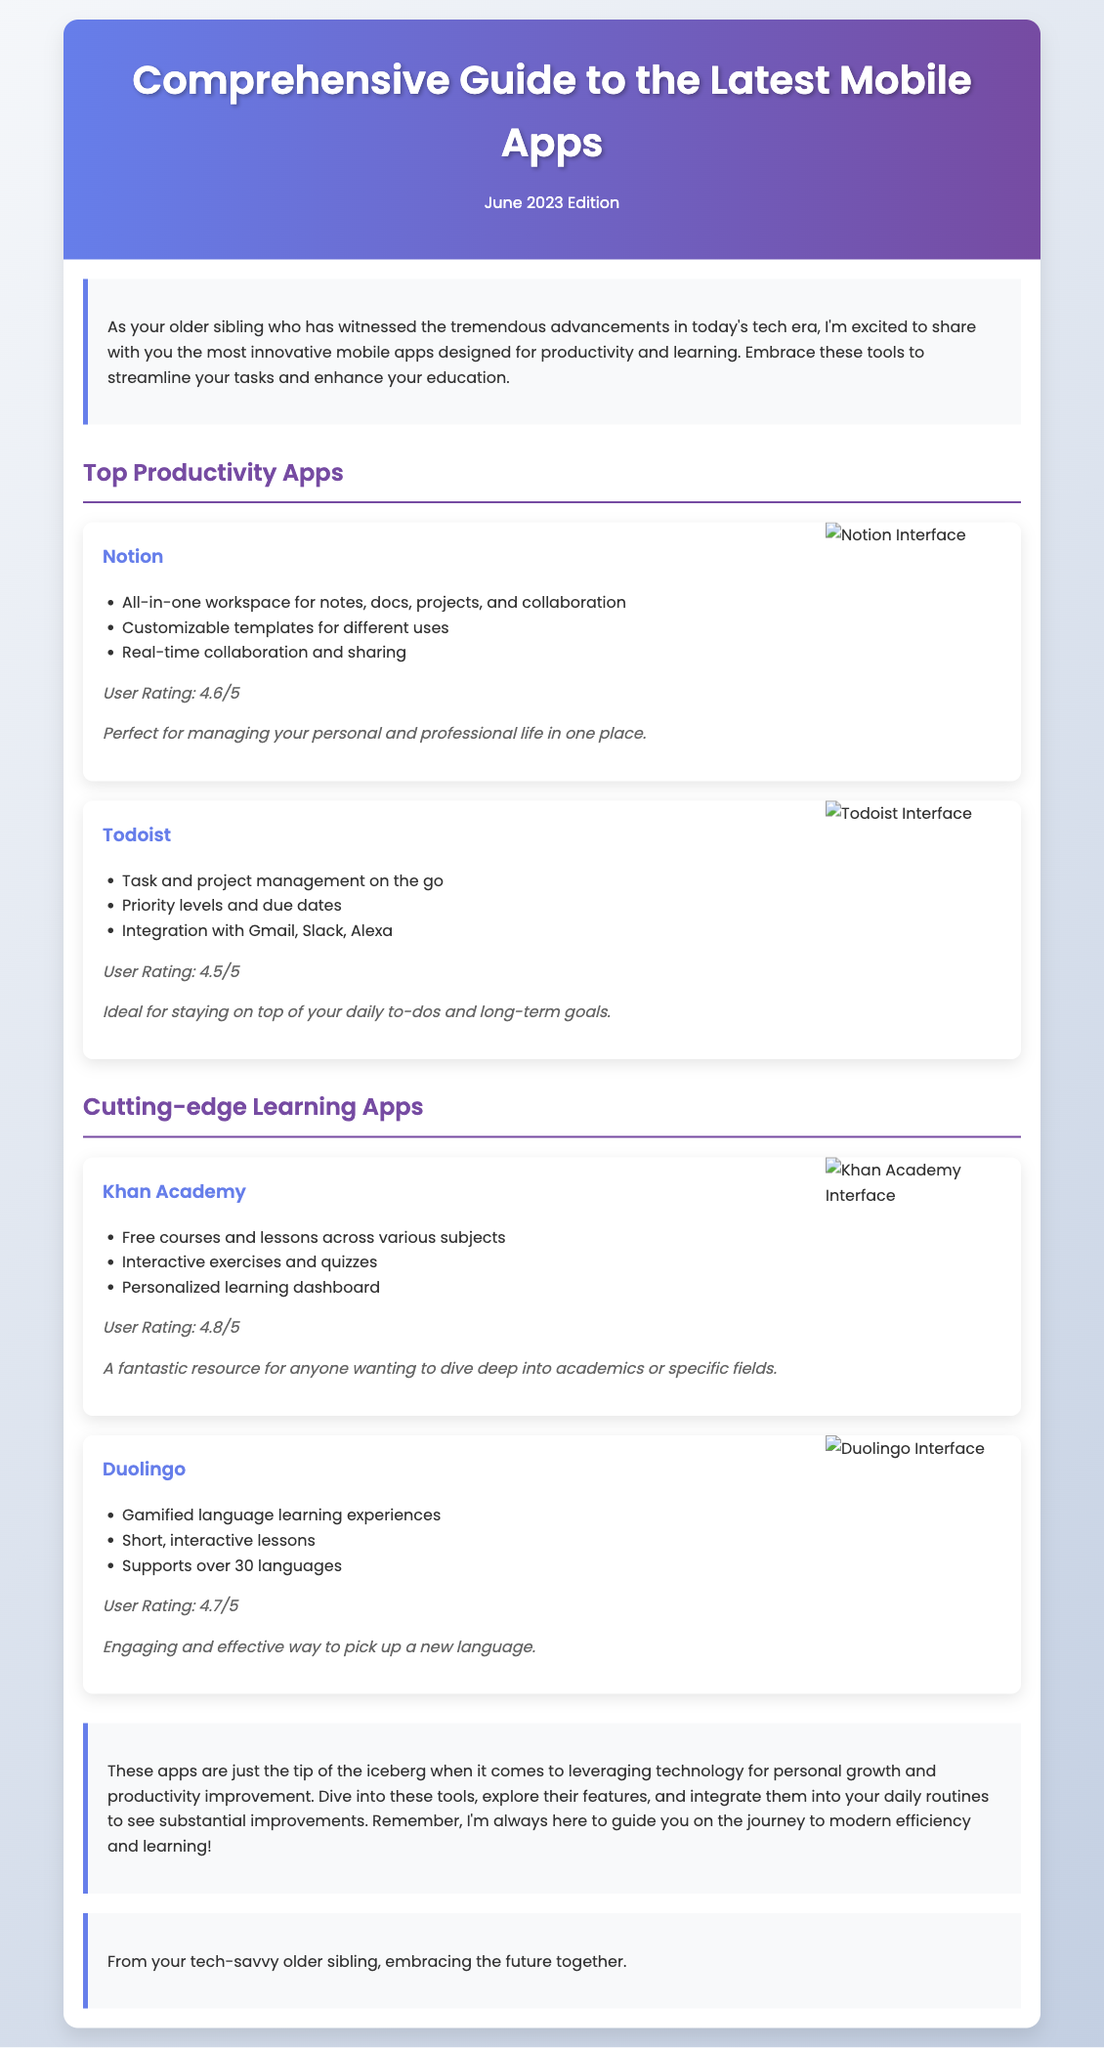What is the title of the guide? The title is prominently displayed in the header of the document.
Answer: Comprehensive Guide to the Latest Mobile Apps What is the publication date of this edition? The publication date is mentioned just below the title in the header.
Answer: June 2023 What is the user rating for Notion? The user rating is listed in the app information section for Notion.
Answer: 4.6/5 Which app is recommended for language learning? The app recommendations are found in the section about learning apps.
Answer: Duolingo What is the primary focus of the guide? This can be inferred from the introduction and headers throughout the document.
Answer: Productivity and Learning How many subjects does Khan Academy cover? The details provided in the Khan Academy section indicate the breadth of the app.
Answer: Various What color scheme is used in the header of the document? The color scheme can be found through a visual examination of the header.
Answer: Gradient of blue and purple Which app is described as ideal for daily to-dos? The recommendation for managing daily tasks is found in the section for productivity apps.
Answer: Todoist What is the recommendation for using these apps? The conclusion summarizes advice on integrating the tools into daily routines.
Answer: Integrate them into your daily routines 